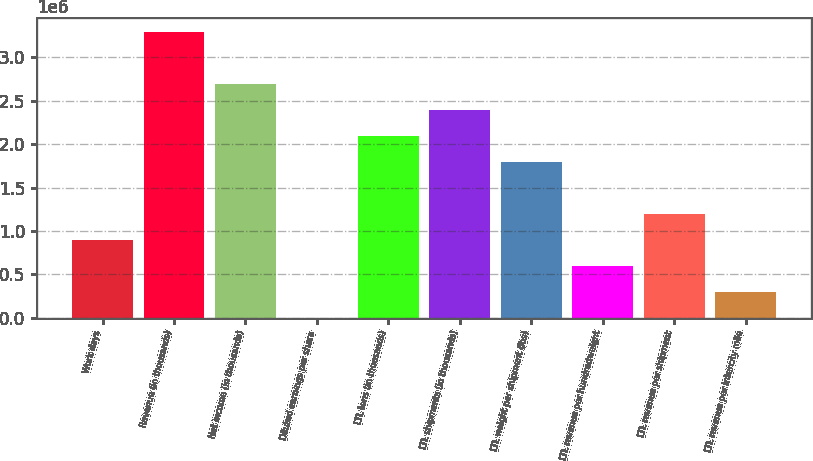<chart> <loc_0><loc_0><loc_500><loc_500><bar_chart><fcel>Work days<fcel>Revenue (in thousands)<fcel>Net income (in thousands)<fcel>Diluted earnings per share<fcel>LTL tons (in thousands)<fcel>LTL shipments (in thousands)<fcel>LTL weight per shipment (lbs)<fcel>LTL revenue per hundredweight<fcel>LTL revenue per shipment<fcel>LTL revenue per intercity mile<nl><fcel>897458<fcel>3.29067e+06<fcel>2.69237e+06<fcel>3.56<fcel>2.09406e+06<fcel>2.39321e+06<fcel>1.79491e+06<fcel>598306<fcel>1.19661e+06<fcel>299155<nl></chart> 